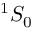Convert formula to latex. <formula><loc_0><loc_0><loc_500><loc_500>^ { 1 } S _ { 0 }</formula> 